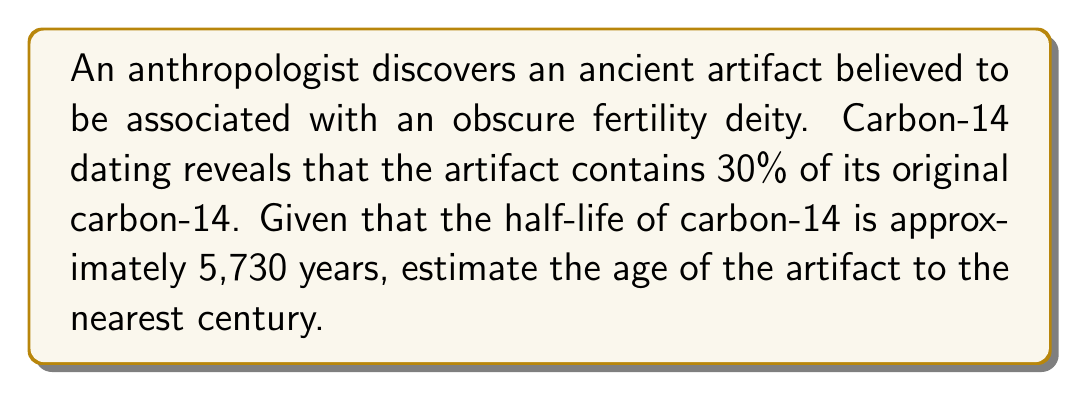Give your solution to this math problem. Let's approach this step-by-step using the exponential decay formula:

1) The exponential decay formula is:
   $$ N(t) = N_0 \cdot (0.5)^{t/t_{1/2}} $$
   Where:
   $N(t)$ is the amount remaining after time $t$
   $N_0$ is the initial amount
   $t$ is the time elapsed
   $t_{1/2}$ is the half-life

2) We know that 30% of the original carbon-14 remains, so:
   $$ 0.30 = (0.5)^{t/5730} $$

3) Taking the natural log of both sides:
   $$ \ln(0.30) = \ln((0.5)^{t/5730}) $$

4) Using the logarithm property $\ln(a^b) = b\ln(a)$:
   $$ \ln(0.30) = (t/5730) \cdot \ln(0.5) $$

5) Solving for $t$:
   $$ t = 5730 \cdot \frac{\ln(0.30)}{\ln(0.5)} $$

6) Calculate:
   $$ t \approx 5730 \cdot \frac{-1.2040}{-0.6931} \approx 9944.8 \text{ years} $$

7) Rounding to the nearest century:
   $$ 9944.8 \text{ years} \approx 9900 \text{ years} $$
Answer: 9900 years 